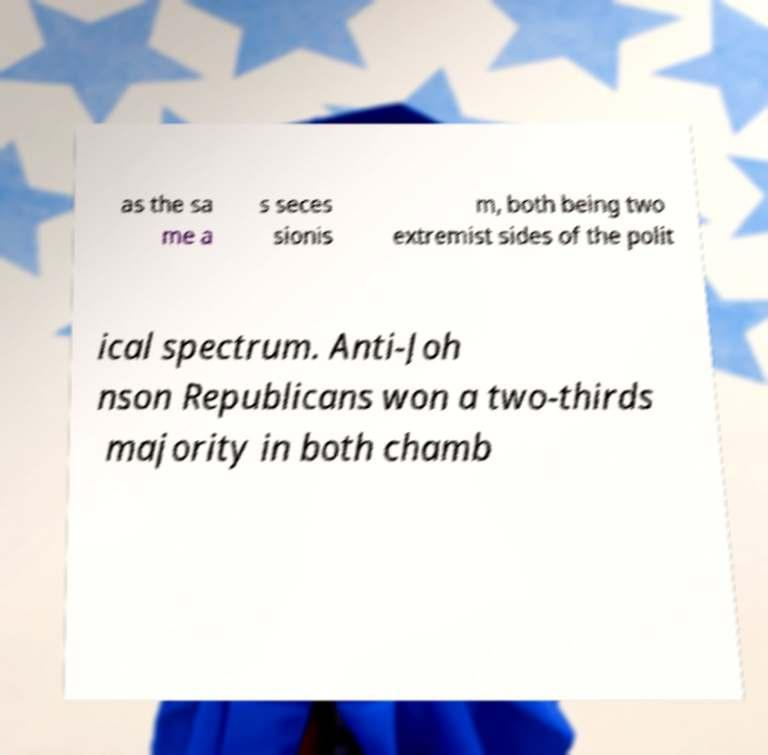What messages or text are displayed in this image? I need them in a readable, typed format. as the sa me a s seces sionis m, both being two extremist sides of the polit ical spectrum. Anti-Joh nson Republicans won a two-thirds majority in both chamb 